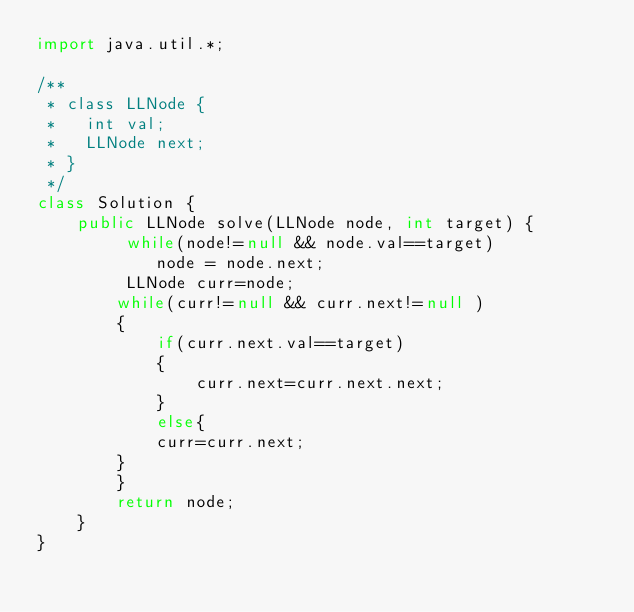<code> <loc_0><loc_0><loc_500><loc_500><_Java_>import java.util.*;

/**
 * class LLNode {
 *   int val;
 *   LLNode next;
 * }
 */
class Solution {
    public LLNode solve(LLNode node, int target) {
         while(node!=null && node.val==target)
            node = node.next;
         LLNode curr=node;
        while(curr!=null && curr.next!=null )  
        {
            if(curr.next.val==target)
            {
                curr.next=curr.next.next;
            }
            else{
            curr=curr.next;
        }
        }
        return node;
    }
}
</code> 